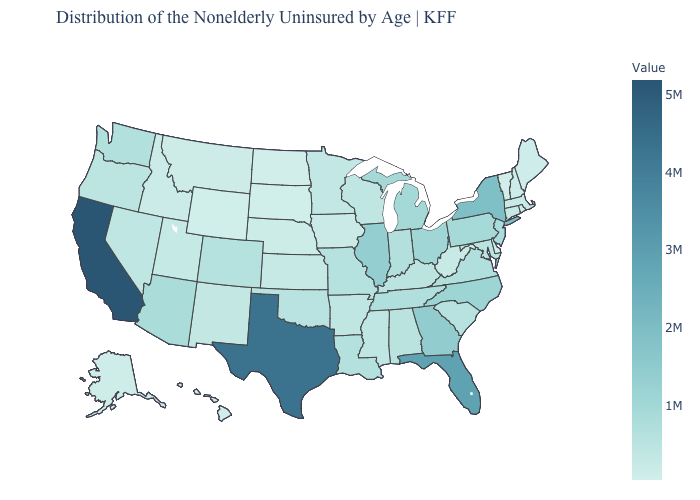Which states have the lowest value in the West?
Quick response, please. Wyoming. Does Missouri have the lowest value in the MidWest?
Give a very brief answer. No. Among the states that border South Dakota , which have the lowest value?
Short answer required. North Dakota. Among the states that border Vermont , which have the lowest value?
Be succinct. New Hampshire. 